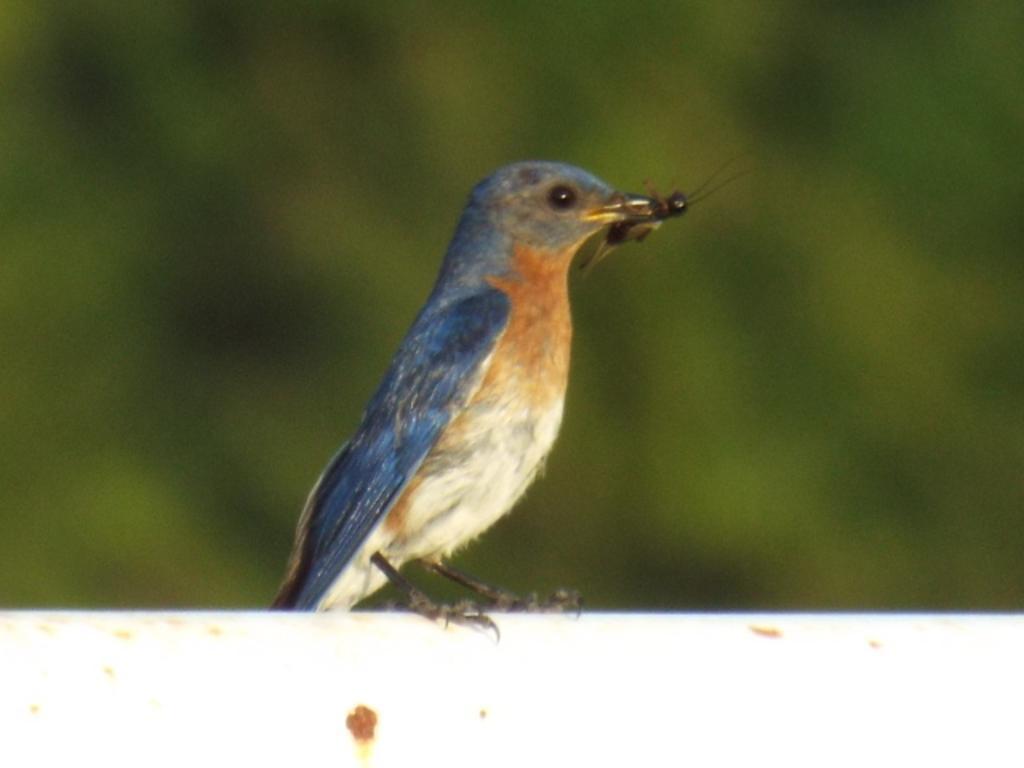In one or two sentences, can you explain what this image depicts? In this image I can see there is a bird and it is holding an insect in its mouth and the background of the image is blurred. 